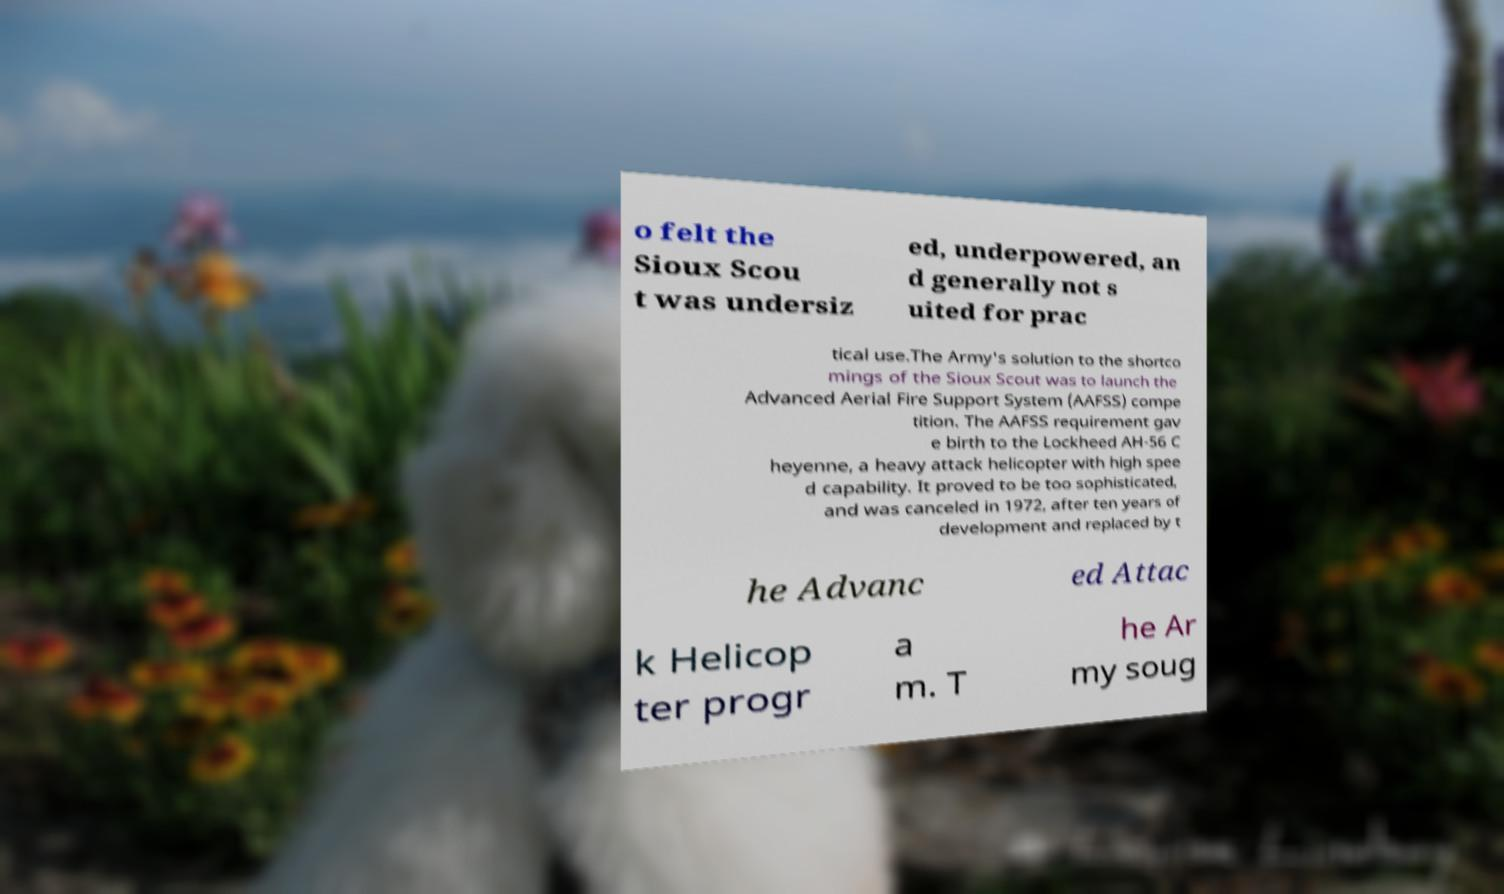Can you accurately transcribe the text from the provided image for me? o felt the Sioux Scou t was undersiz ed, underpowered, an d generally not s uited for prac tical use.The Army's solution to the shortco mings of the Sioux Scout was to launch the Advanced Aerial Fire Support System (AAFSS) compe tition. The AAFSS requirement gav e birth to the Lockheed AH-56 C heyenne, a heavy attack helicopter with high spee d capability. It proved to be too sophisticated, and was canceled in 1972, after ten years of development and replaced by t he Advanc ed Attac k Helicop ter progr a m. T he Ar my soug 